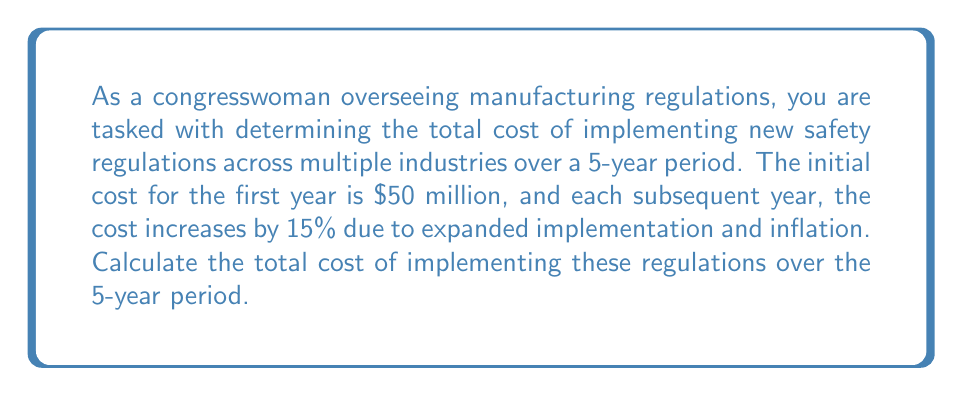Can you solve this math problem? To solve this problem, we need to recognize that this is a geometric sequence with a common ratio of 1.15 (15% increase each year).

Let's define our sequence:
$a_1 = 50$ million (initial cost)
$r = 1.15$ (common ratio)
$n = 5$ (number of years)

The costs for each year will be:
Year 1: $a_1 = 50$ million
Year 2: $a_2 = 50 \times 1.15 = 57.5$ million
Year 3: $a_3 = 57.5 \times 1.15 = 66.125$ million
Year 4: $a_4 = 66.125 \times 1.15 = 76.04375$ million
Year 5: $a_5 = 76.04375 \times 1.15 = 87.4503125$ million

To find the total cost, we need to sum this geometric sequence. We can use the formula for the sum of a geometric series:

$$S_n = \frac{a_1(1-r^n)}{1-r}$$

Where:
$S_n$ is the sum of the series
$a_1$ is the first term
$r$ is the common ratio
$n$ is the number of terms

Plugging in our values:

$$S_5 = \frac{50(1-1.15^5)}{1-1.15}$$

$$S_5 = \frac{50(1-2.011356)}{-0.15}$$

$$S_5 = \frac{50(-1.011356)}{-0.15}$$

$$S_5 = 337.1187$$

Therefore, the total cost over the 5-year period is approximately $337.12 million.
Answer: $337.12 million 